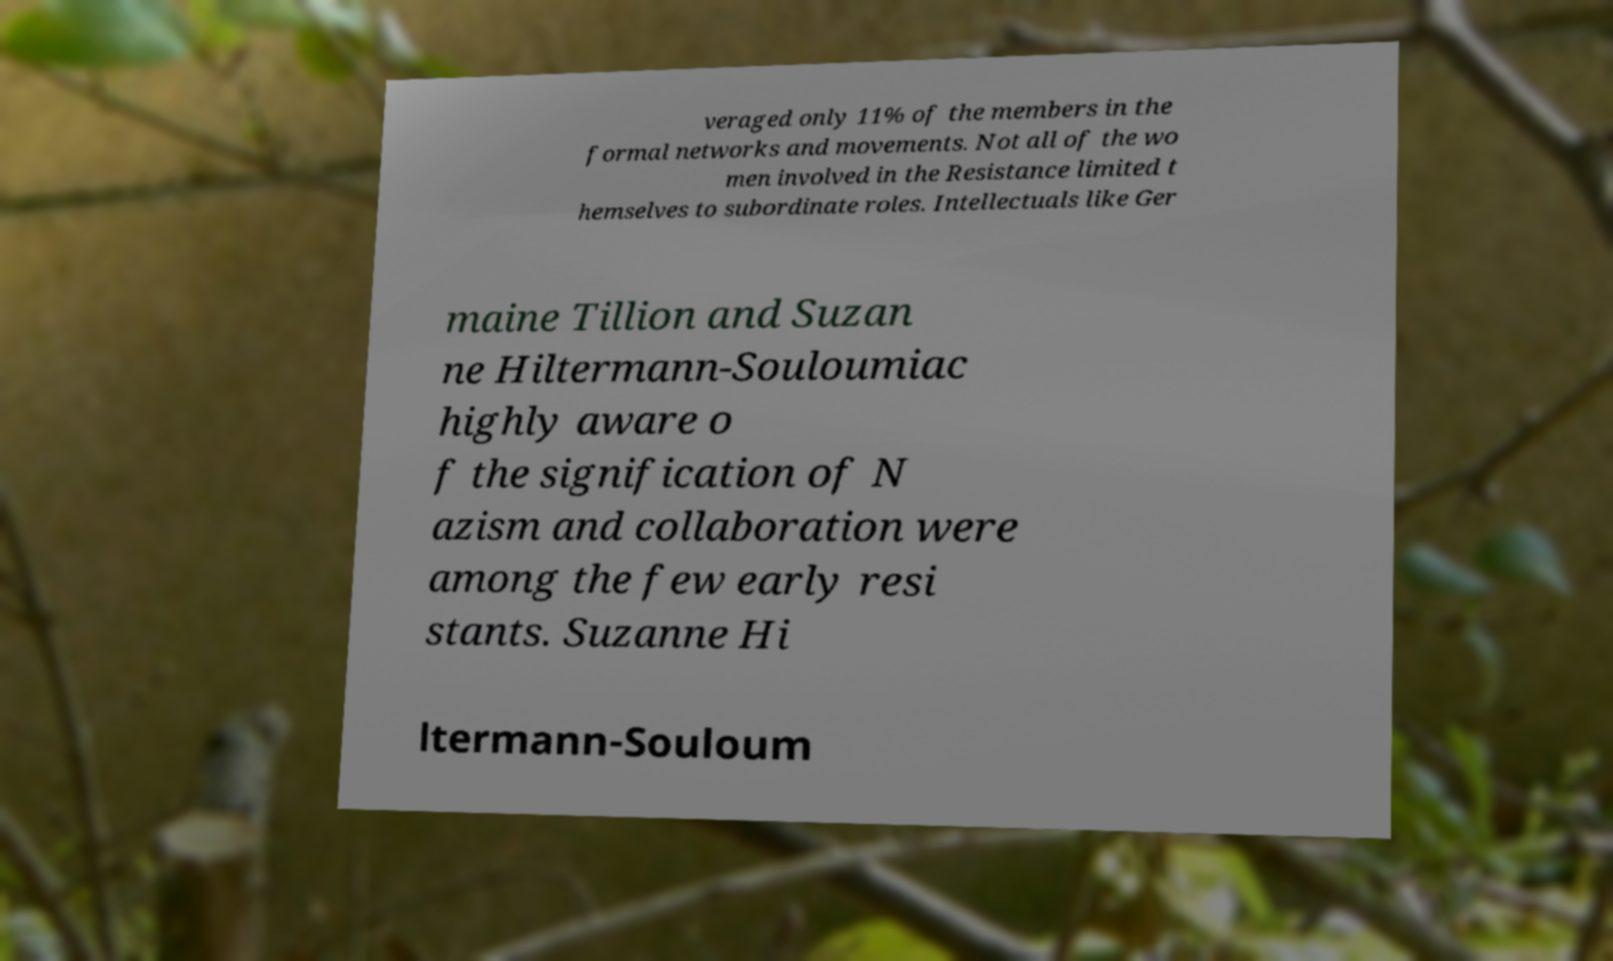Could you assist in decoding the text presented in this image and type it out clearly? veraged only 11% of the members in the formal networks and movements. Not all of the wo men involved in the Resistance limited t hemselves to subordinate roles. Intellectuals like Ger maine Tillion and Suzan ne Hiltermann-Souloumiac highly aware o f the signification of N azism and collaboration were among the few early resi stants. Suzanne Hi ltermann-Souloum 